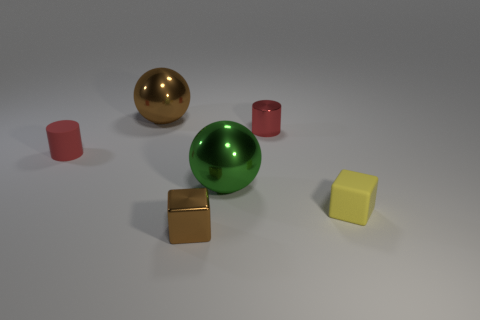Add 4 small brown things. How many objects exist? 10 Subtract all cylinders. How many objects are left? 4 Add 4 rubber things. How many rubber things are left? 6 Add 5 small yellow things. How many small yellow things exist? 6 Subtract 1 green balls. How many objects are left? 5 Subtract all balls. Subtract all small cubes. How many objects are left? 2 